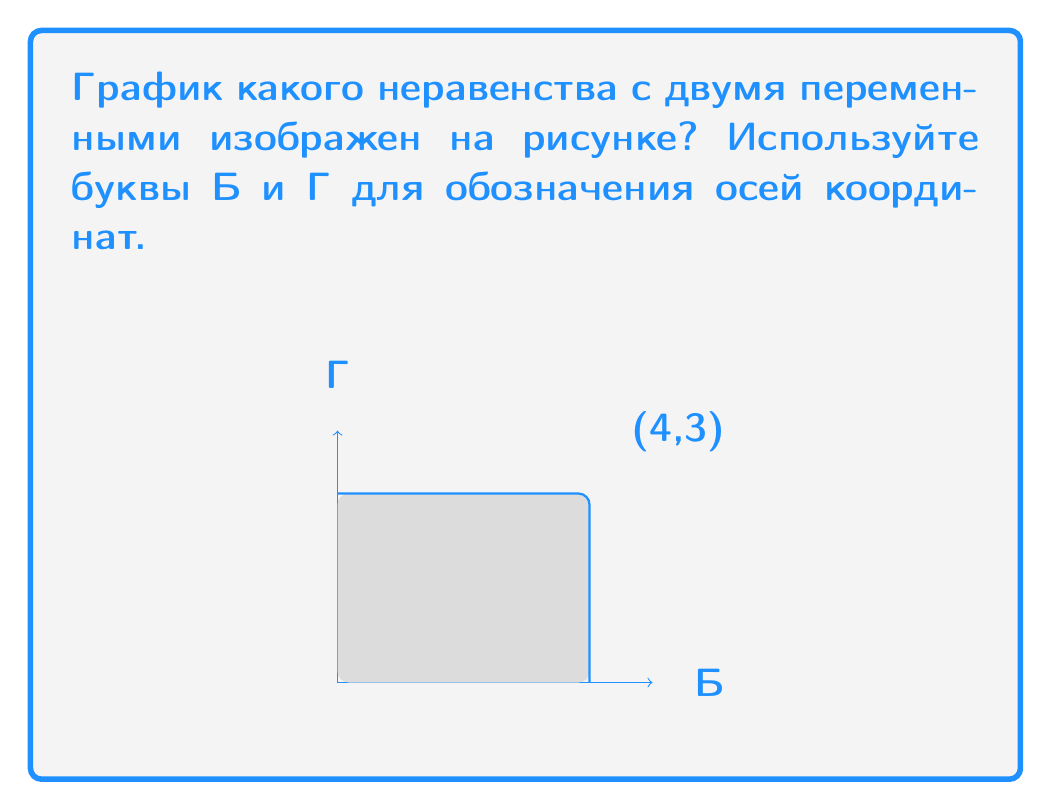Solve this math problem. Давайте разберем это шаг за шагом:

1) На графике мы видим закрашенную область, ограниченную прямыми линиями.

2) Граница области включает в себя горизонтальную линию от (0,3) до (4,3) и вертикальную линию от (4,3) до (4,0).

3) Эти линии соответствуют уравнениям:
   Г = 3 (горизонтальная линия)
   Б = 4 (вертикальная линия)

4) Область закрашена ниже и левее этих линий, что означает, что мы ищем неравенства "меньше или равно" (≤).

5) Таким образом, наше неравенство должно включать:
   Г ≤ 3 и Б ≤ 4

6) В системе неравенств эти условия объединяются с помощью логического "и", что в математической записи обозначается знаком ∧.

7) Итоговое неравенство: Г ≤ 3 ∧ Б ≤ 4

8) В более привычной для изучающих русский язык форме это можно записать как:
   $$ Г \leq 3 \text{ и } Б \leq 4 $$
Answer: $$ Г \leq 3 \text{ и } Б \leq 4 $$ 